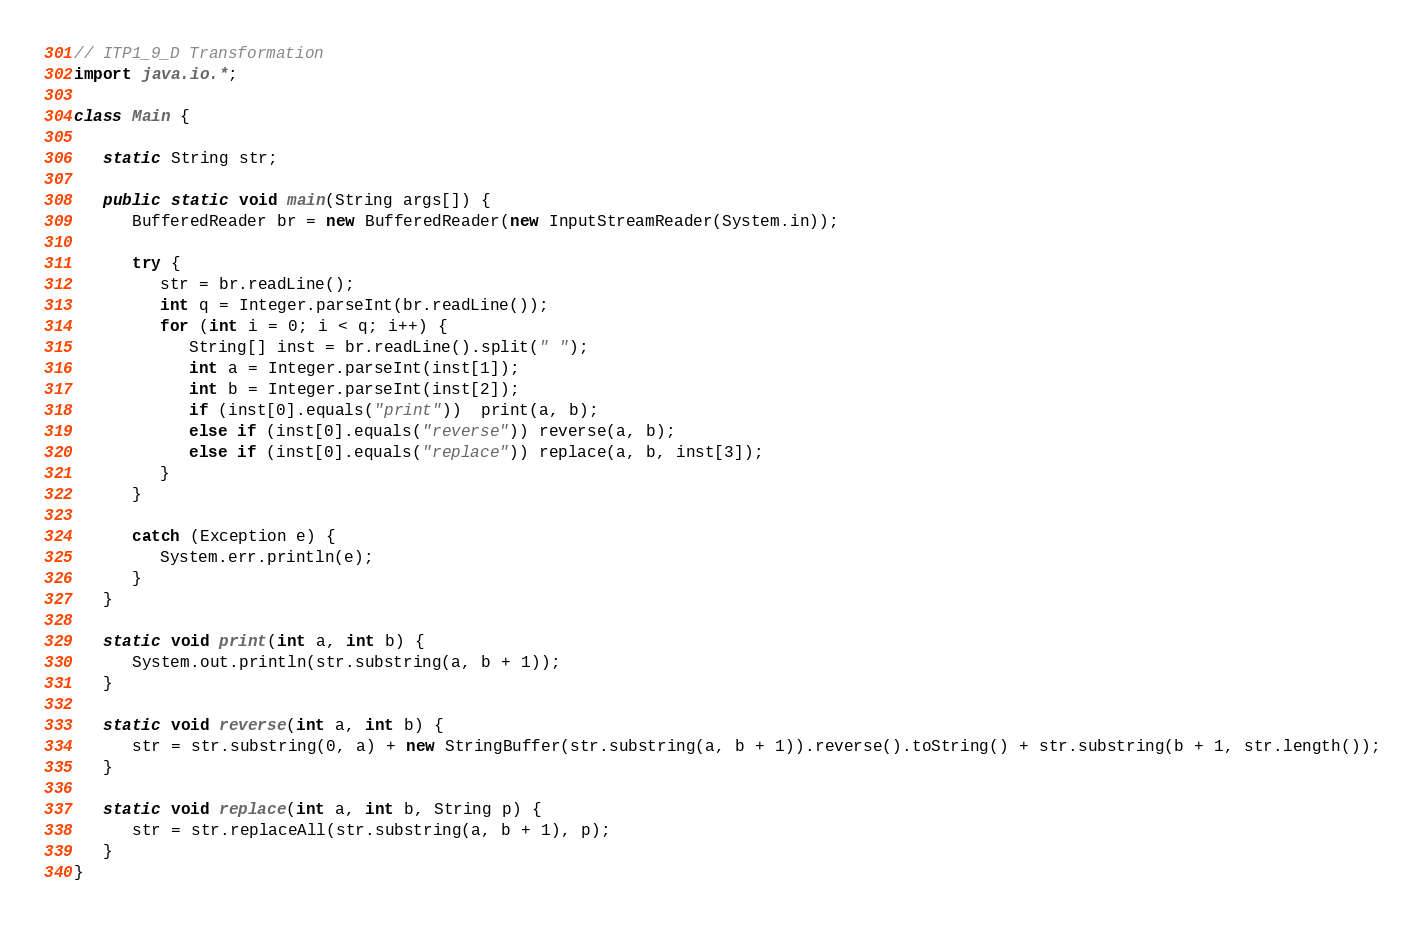<code> <loc_0><loc_0><loc_500><loc_500><_Java_>// ITP1_9_D Transformation
import java.io.*;

class Main {

   static String str;

   public static void main(String args[]) {
      BufferedReader br = new BufferedReader(new InputStreamReader(System.in));

      try {
         str = br.readLine();
         int q = Integer.parseInt(br.readLine());
         for (int i = 0; i < q; i++) {
            String[] inst = br.readLine().split(" ");
            int a = Integer.parseInt(inst[1]);
            int b = Integer.parseInt(inst[2]);
            if (inst[0].equals("print"))  print(a, b);
            else if (inst[0].equals("reverse")) reverse(a, b);
            else if (inst[0].equals("replace")) replace(a, b, inst[3]);
         }
      }

      catch (Exception e) {
         System.err.println(e);
      }
   }

   static void print(int a, int b) {
      System.out.println(str.substring(a, b + 1));
   }

   static void reverse(int a, int b) {
      str = str.substring(0, a) + new StringBuffer(str.substring(a, b + 1)).reverse().toString() + str.substring(b + 1, str.length());
   }

   static void replace(int a, int b, String p) {
      str = str.replaceAll(str.substring(a, b + 1), p); 
   }
}</code> 